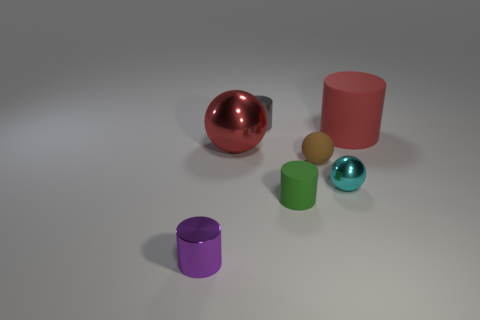Is the material of the red cylinder the same as the tiny brown object?
Ensure brevity in your answer.  Yes. What number of yellow objects are either large rubber cylinders or tiny matte cylinders?
Your answer should be very brief. 0. Is the number of metallic things that are in front of the red metal thing greater than the number of red shiny objects?
Your answer should be compact. Yes. Is there a rubber object of the same color as the large sphere?
Keep it short and to the point. Yes. What is the size of the red cylinder?
Offer a very short reply. Large. Do the large sphere and the big cylinder have the same color?
Give a very brief answer. Yes. What number of things are either big cyan shiny spheres or balls behind the tiny cyan object?
Your answer should be very brief. 2. There is a large red object left of the cylinder that is behind the large rubber thing; what number of small metal things are right of it?
Your response must be concise. 2. What is the material of the sphere that is the same color as the large rubber cylinder?
Make the answer very short. Metal. How many tiny rubber spheres are there?
Offer a very short reply. 1. 